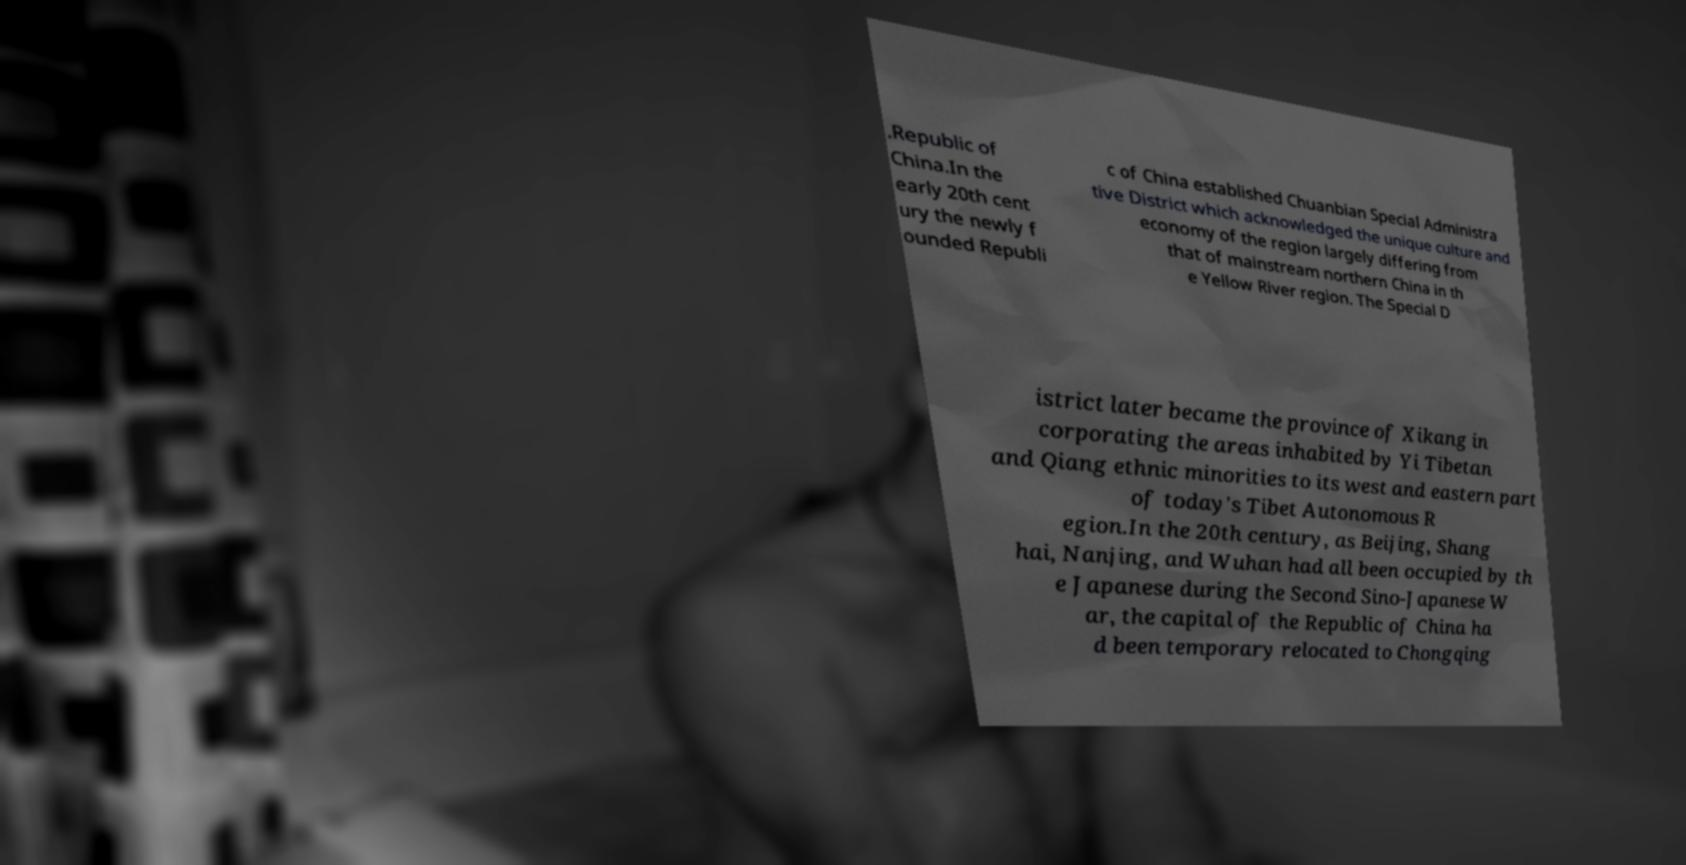Could you extract and type out the text from this image? .Republic of China.In the early 20th cent ury the newly f ounded Republi c of China established Chuanbian Special Administra tive District which acknowledged the unique culture and economy of the region largely differing from that of mainstream northern China in th e Yellow River region. The Special D istrict later became the province of Xikang in corporating the areas inhabited by Yi Tibetan and Qiang ethnic minorities to its west and eastern part of today's Tibet Autonomous R egion.In the 20th century, as Beijing, Shang hai, Nanjing, and Wuhan had all been occupied by th e Japanese during the Second Sino-Japanese W ar, the capital of the Republic of China ha d been temporary relocated to Chongqing 